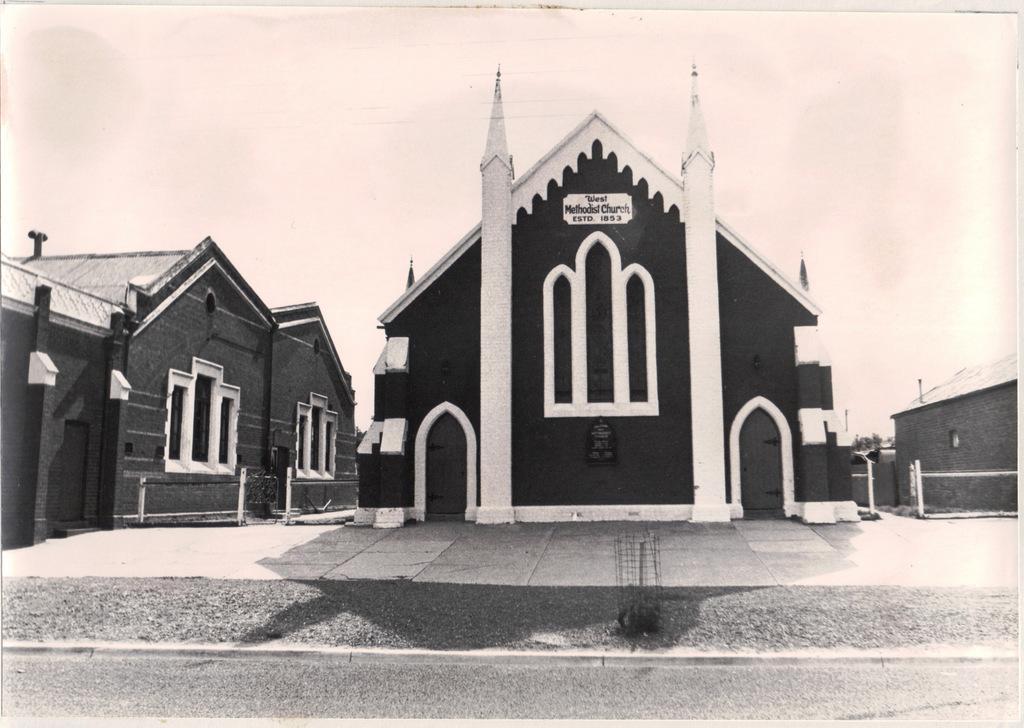In one or two sentences, can you explain what this image depicts? In this image in front there is a road. In the center of the image there are buildings. There is a metal fence. In the background of the image there is sky. 